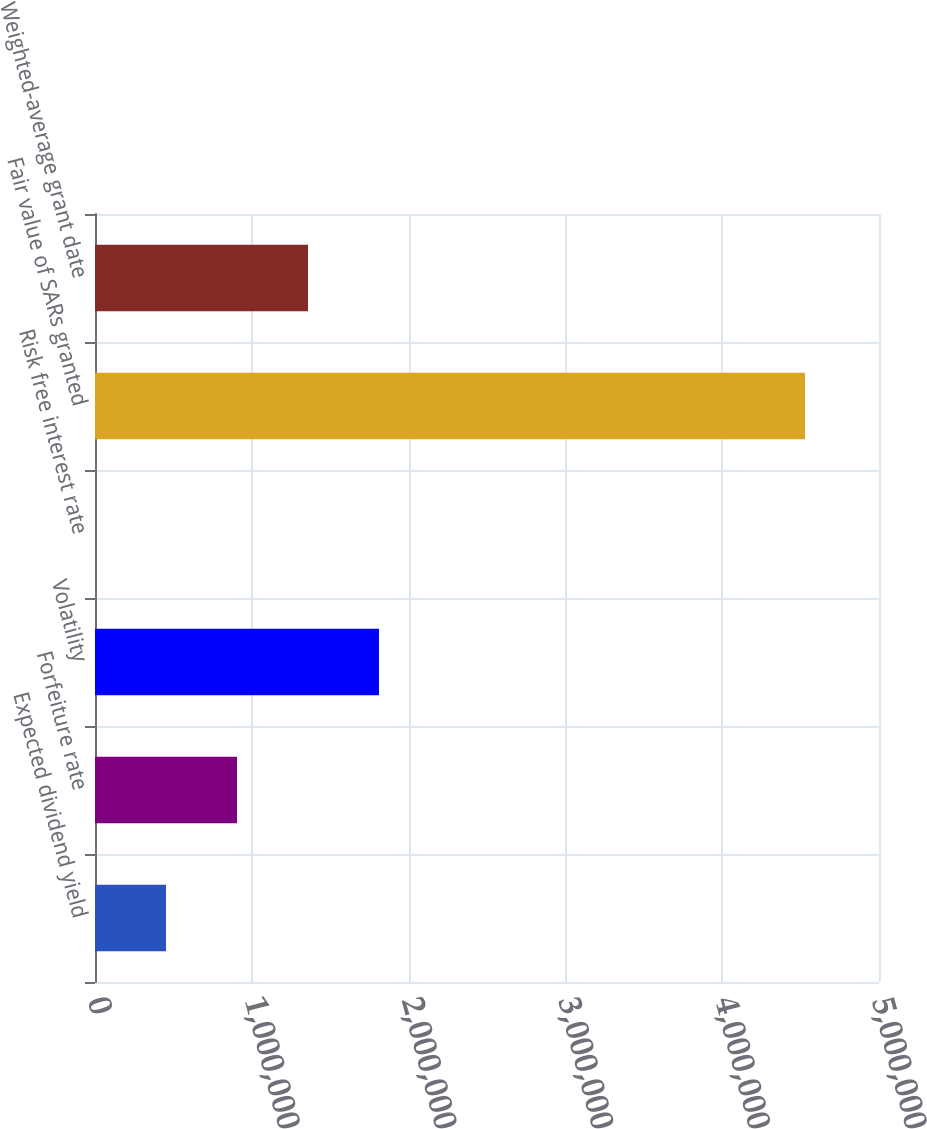Convert chart. <chart><loc_0><loc_0><loc_500><loc_500><bar_chart><fcel>Expected dividend yield<fcel>Forfeiture rate<fcel>Volatility<fcel>Risk free interest rate<fcel>Fair value of SARs granted<fcel>Weighted-average grant date<nl><fcel>452801<fcel>905601<fcel>1.8112e+06<fcel>0.82<fcel>4.528e+06<fcel>1.3584e+06<nl></chart> 